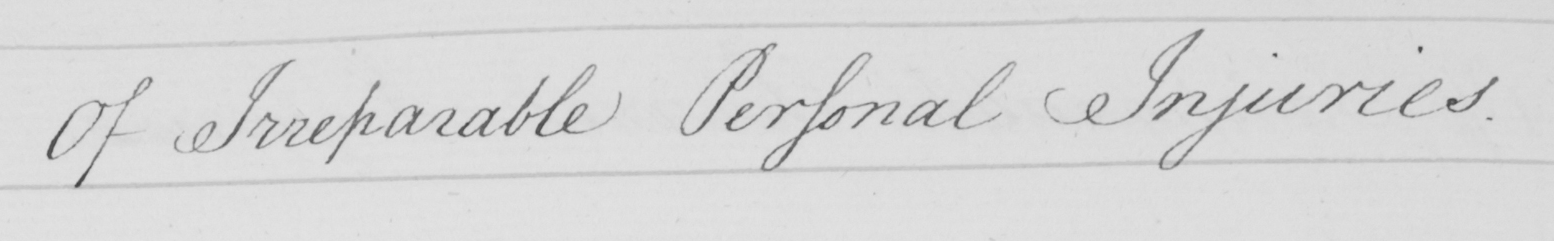Can you read and transcribe this handwriting? Of Irreparable Personal Injuries 